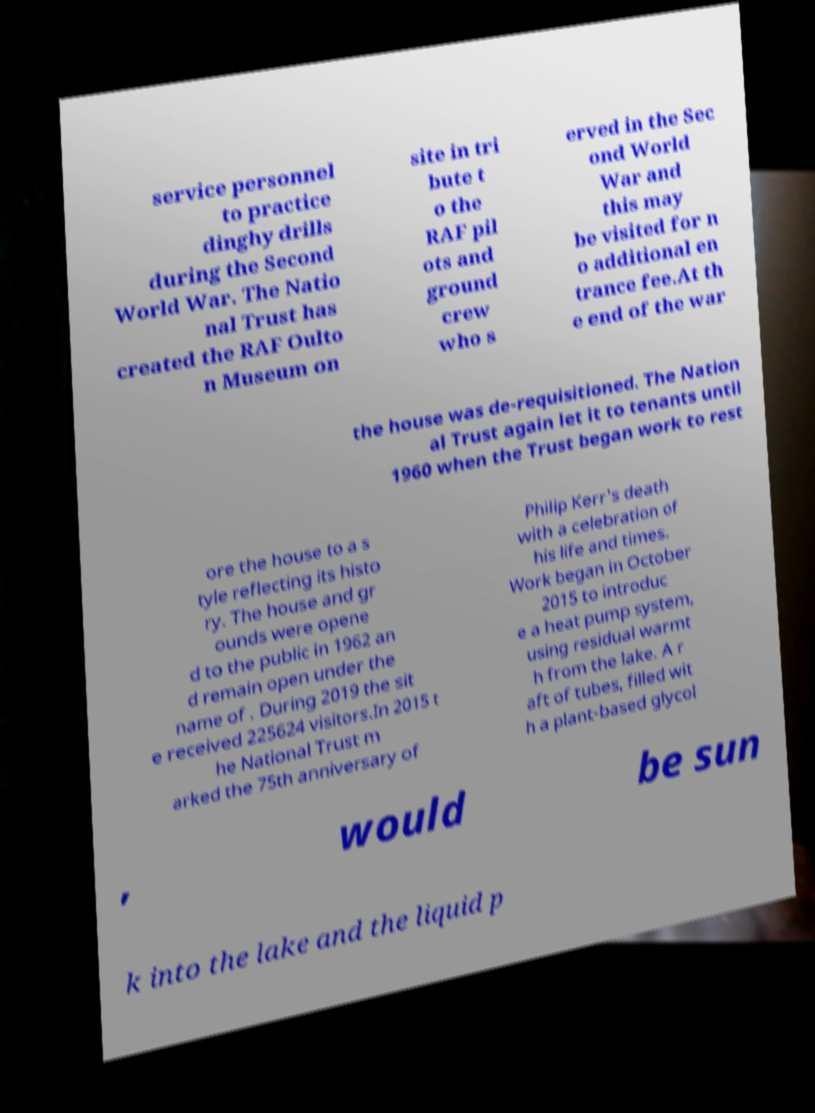For documentation purposes, I need the text within this image transcribed. Could you provide that? service personnel to practice dinghy drills during the Second World War. The Natio nal Trust has created the RAF Oulto n Museum on site in tri bute t o the RAF pil ots and ground crew who s erved in the Sec ond World War and this may be visited for n o additional en trance fee.At th e end of the war the house was de-requisitioned. The Nation al Trust again let it to tenants until 1960 when the Trust began work to rest ore the house to a s tyle reflecting its histo ry. The house and gr ounds were opene d to the public in 1962 an d remain open under the name of . During 2019 the sit e received 225624 visitors.In 2015 t he National Trust m arked the 75th anniversary of Philip Kerr's death with a celebration of his life and times. Work began in October 2015 to introduc e a heat pump system, using residual warmt h from the lake. A r aft of tubes, filled wit h a plant-based glycol , would be sun k into the lake and the liquid p 